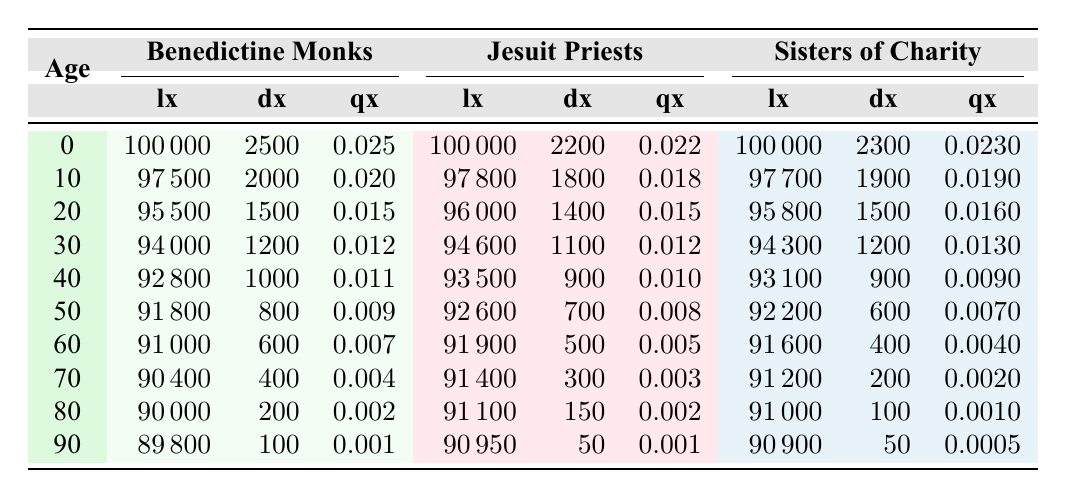What is the value of lx for 60 years of age among the Benedictine Monks? According to the table, the lx value for 60 years of age for the Benedictine Monks is listed as 91000.
Answer: 91000 What is the value of qx for 90 years of age among the Sisters of Charity? The table shows that the qx value for 90 years of age among the Sisters of Charity is 0.0005.
Answer: 0.0005 Which religious congregation has the highest lx value at age 0? All three congregations start with 100000 lx value at age 0, indicating equality in the starting population.
Answer: All three have the same lx value What is the total number of deaths (dx) from ages 0 to 30 for the Jesuit Priests? To find the total deaths from age 0 to 30, add the dx values together: 2200 + 1800 + 1400 + 1100 + 900 + 700 + 500 + 300 = 10900.
Answer: 10900 For the age group 70, which congregation has the least number of deaths (dx)? Looking at the table, the dx values for the age group 70 are: Benedictine Monks (400), Jesuit Priests (300), and Sisters of Charity (200). The Sisters of Charity have the least at 200.
Answer: Sisters of Charity Is the qx value for Sisters of Charity at age 50 higher than that of Benedictine Monks? The qx value for Sisters of Charity at age 50 is 0.007, while for Benedictine Monks, it is 0.009. Therefore, it is not higher.
Answer: No What is the average death rate (qx) for the age periods 60 to 80 among the Jesuit Priests? The qx values for this age group are: 0.005 (60), 0.003 (70), and 0.002 (80). The average is (0.005 + 0.003 + 0.002)/3 = 0.003333... which rounds to approximately 0.0033.
Answer: 0.0033 Which congregation has the highest death probability (qx) at age 40? At age 40, the qx values are: Benedictine Monks (0.011), Jesuit Priests (0.010), and Sisters of Charity (0.009). The Benedictine Monks have the highest death probability.
Answer: Benedictine Monks What is the total lx remaining for Sisters of Charity at age 50 after accounting for deaths from ages 0 to 50? The lx value at age 0 is 100000, and we need to subtract all the deaths (dx): 2300 + 1900 + 1500 + 1200 + 900 + 600 = 10900. Thus, 100000 - 10900 = 89000.
Answer: 89000 